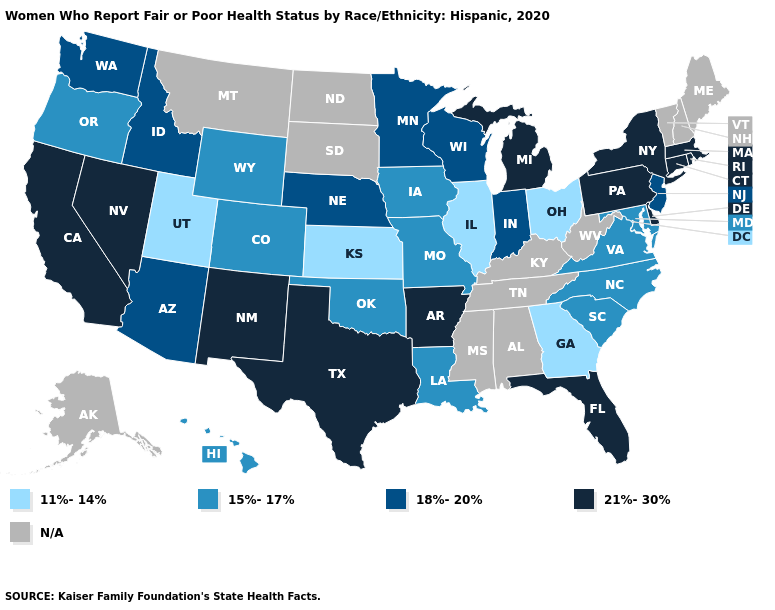Which states have the lowest value in the USA?
Write a very short answer. Georgia, Illinois, Kansas, Ohio, Utah. Name the states that have a value in the range 21%-30%?
Short answer required. Arkansas, California, Connecticut, Delaware, Florida, Massachusetts, Michigan, Nevada, New Mexico, New York, Pennsylvania, Rhode Island, Texas. Among the states that border Arkansas , does Louisiana have the lowest value?
Answer briefly. Yes. Name the states that have a value in the range N/A?
Be succinct. Alabama, Alaska, Kentucky, Maine, Mississippi, Montana, New Hampshire, North Dakota, South Dakota, Tennessee, Vermont, West Virginia. Does New Jersey have the highest value in the USA?
Be succinct. No. Name the states that have a value in the range 18%-20%?
Short answer required. Arizona, Idaho, Indiana, Minnesota, Nebraska, New Jersey, Washington, Wisconsin. Among the states that border Ohio , which have the lowest value?
Keep it brief. Indiana. Is the legend a continuous bar?
Concise answer only. No. What is the highest value in states that border Washington?
Quick response, please. 18%-20%. Name the states that have a value in the range 21%-30%?
Short answer required. Arkansas, California, Connecticut, Delaware, Florida, Massachusetts, Michigan, Nevada, New Mexico, New York, Pennsylvania, Rhode Island, Texas. Name the states that have a value in the range 11%-14%?
Write a very short answer. Georgia, Illinois, Kansas, Ohio, Utah. Name the states that have a value in the range 21%-30%?
Write a very short answer. Arkansas, California, Connecticut, Delaware, Florida, Massachusetts, Michigan, Nevada, New Mexico, New York, Pennsylvania, Rhode Island, Texas. What is the value of Delaware?
Answer briefly. 21%-30%. Among the states that border Rhode Island , which have the highest value?
Keep it brief. Connecticut, Massachusetts. 